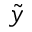Convert formula to latex. <formula><loc_0><loc_0><loc_500><loc_500>\tilde { y }</formula> 